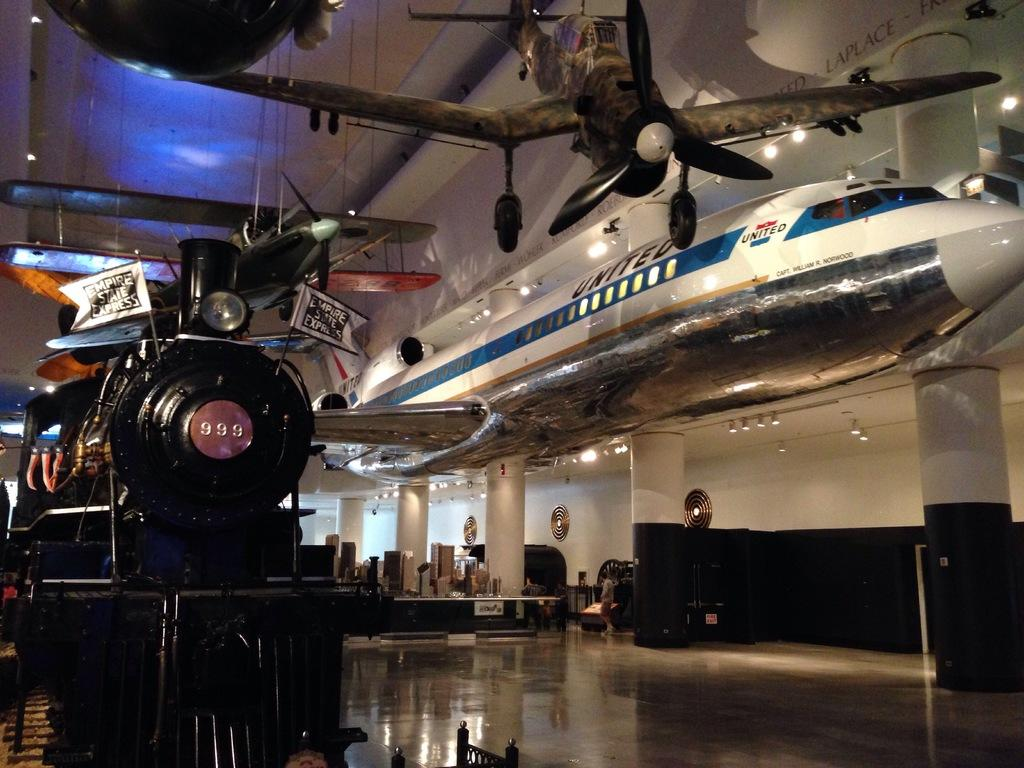<image>
Share a concise interpretation of the image provided. In a room, the Empire State Express train with 999 on the front is surrounded by planes hanging from the ceiling. 